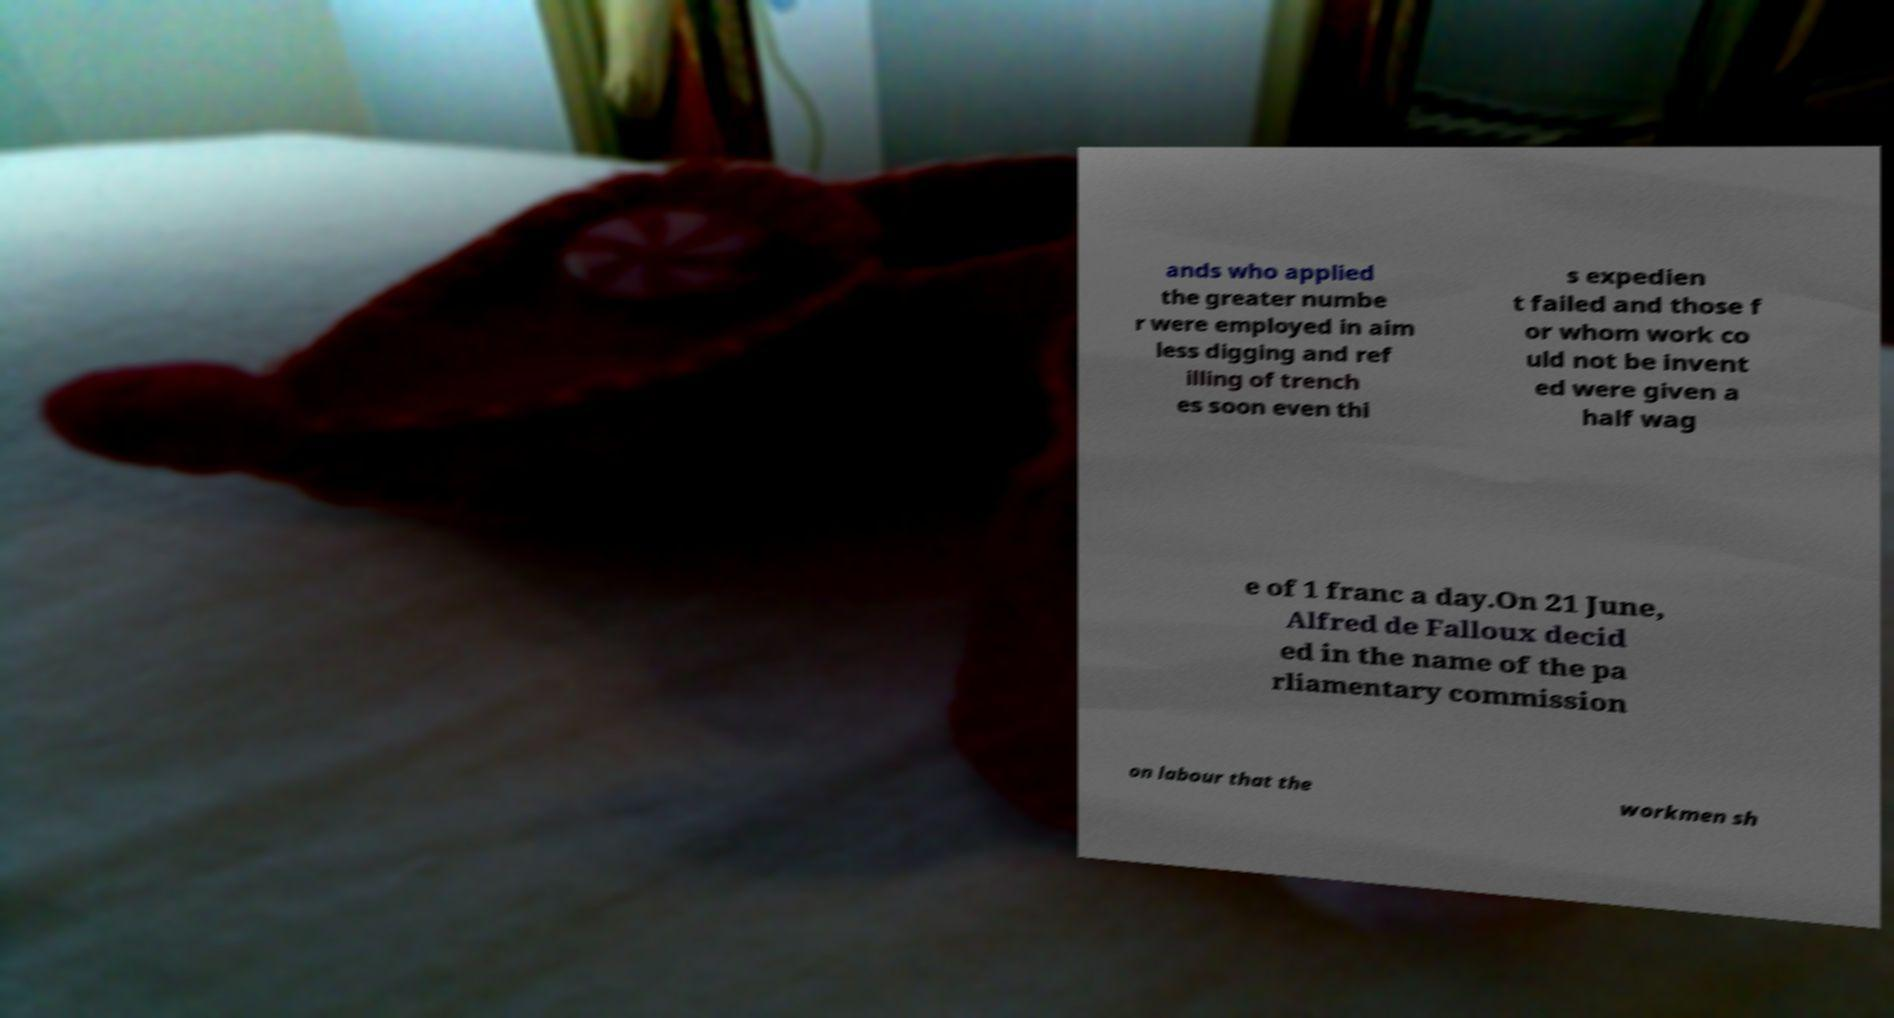What messages or text are displayed in this image? I need them in a readable, typed format. ands who applied the greater numbe r were employed in aim less digging and ref illing of trench es soon even thi s expedien t failed and those f or whom work co uld not be invent ed were given a half wag e of 1 franc a day.On 21 June, Alfred de Falloux decid ed in the name of the pa rliamentary commission on labour that the workmen sh 